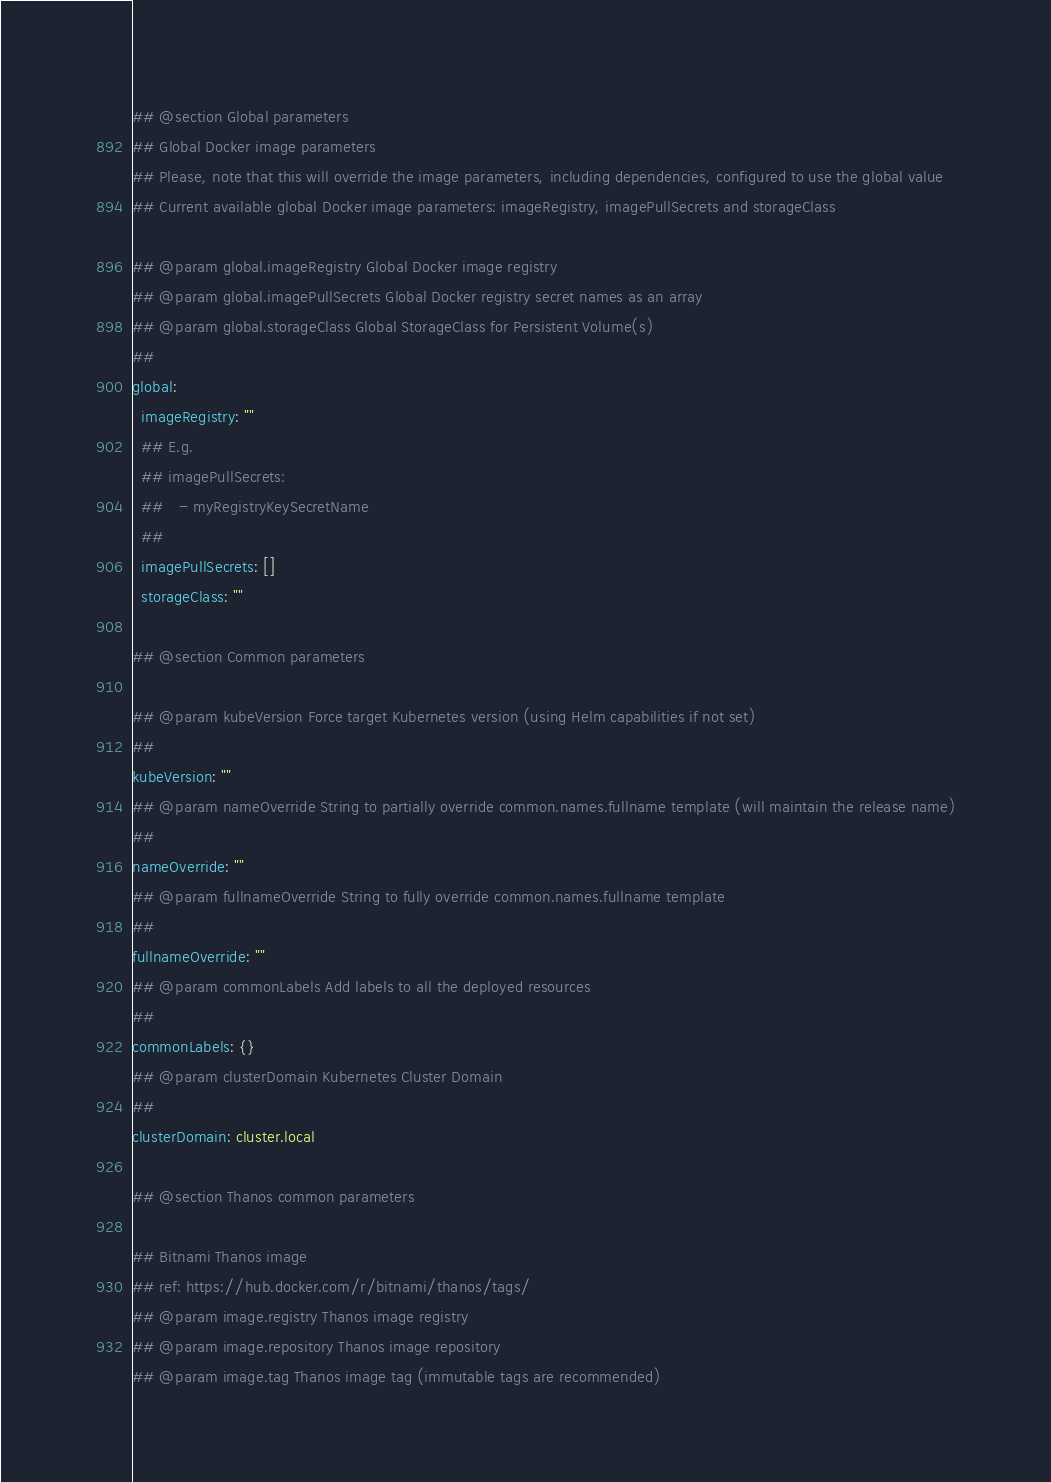Convert code to text. <code><loc_0><loc_0><loc_500><loc_500><_YAML_>## @section Global parameters
## Global Docker image parameters
## Please, note that this will override the image parameters, including dependencies, configured to use the global value
## Current available global Docker image parameters: imageRegistry, imagePullSecrets and storageClass

## @param global.imageRegistry Global Docker image registry
## @param global.imagePullSecrets Global Docker registry secret names as an array
## @param global.storageClass Global StorageClass for Persistent Volume(s)
##
global:
  imageRegistry: ""
  ## E.g.
  ## imagePullSecrets:
  ##   - myRegistryKeySecretName
  ##
  imagePullSecrets: []
  storageClass: ""

## @section Common parameters

## @param kubeVersion Force target Kubernetes version (using Helm capabilities if not set)
##
kubeVersion: ""
## @param nameOverride String to partially override common.names.fullname template (will maintain the release name)
##
nameOverride: ""
## @param fullnameOverride String to fully override common.names.fullname template
##
fullnameOverride: ""
## @param commonLabels Add labels to all the deployed resources
##
commonLabels: {}
## @param clusterDomain Kubernetes Cluster Domain
##
clusterDomain: cluster.local

## @section Thanos common parameters

## Bitnami Thanos image
## ref: https://hub.docker.com/r/bitnami/thanos/tags/
## @param image.registry Thanos image registry
## @param image.repository Thanos image repository
## @param image.tag Thanos image tag (immutable tags are recommended)</code> 